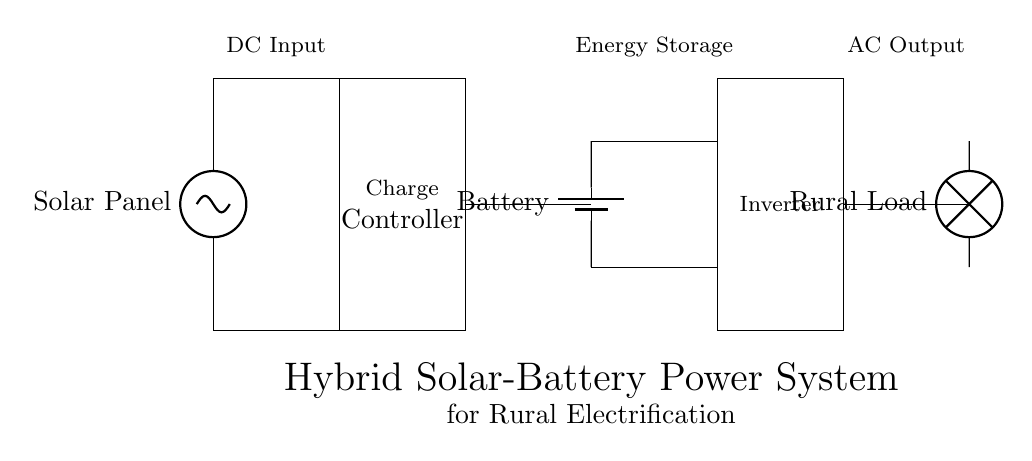What is the main power source in this circuit? The main power source is the solar panel, which converts solar energy into electrical energy. This can be identified in the circuit diagram as the component labeled "Solar Panel" on the left side.
Answer: Solar panel What component is responsible for regulating the energy before it reaches the battery? The charge controller is the component that regulates the voltage and current coming from the solar panel to ensure proper charging of the battery. This is indicated by the rectangle labeled "Charge Controller" connected to the solar panel and the battery.
Answer: Charge controller How many storage devices are present in this circuit? The circuit features one storage device, which is the battery. This can be seen in the diagram where the battery is represented and connected to the charge controller.
Answer: One What is the function of the inverter in this circuit? The inverter's function is to convert the direct current (DC) from the battery into alternating current (AC), which is then used to power the rural load. This can be inferred from the inverter's position in the circuit, where it is connected to the battery and the load.
Answer: Convert DC to AC How does the solar panel connect to the load? The solar panel connects to the load indirectly through the charge controller and the battery, as the solar panel feeds energy to the charge controller, which sends it to the battery, and ultimately the inverter converts the battery power for the load. The connections in the diagram demonstrate this sequence.
Answer: Indirectly through charge controller and battery What type of load is indicated in the circuit? The indicated load is a rural load, meaning it is designed to be used in a rural electrification context. This is specified in the diagram as the component labeled "Rural Load".
Answer: Rural load 